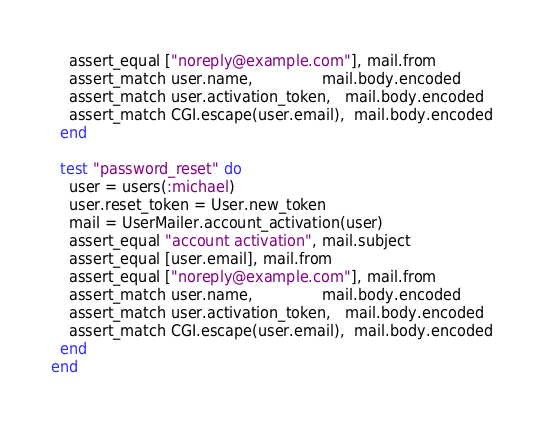Convert code to text. <code><loc_0><loc_0><loc_500><loc_500><_Ruby_>    assert_equal ["noreply@example.com"], mail.from
    assert_match user.name,               mail.body.encoded
    assert_match user.activation_token,   mail.body.encoded
    assert_match CGI.escape(user.email),  mail.body.encoded
  end

  test "password_reset" do
    user = users(:michael)
    user.reset_token = User.new_token
    mail = UserMailer.account_activation(user)
    assert_equal "account activation", mail.subject
    assert_equal [user.email], mail.from
    assert_equal ["noreply@example.com"], mail.from
    assert_match user.name,               mail.body.encoded
    assert_match user.activation_token,   mail.body.encoded
    assert_match CGI.escape(user.email),  mail.body.encoded
  end
end
</code> 